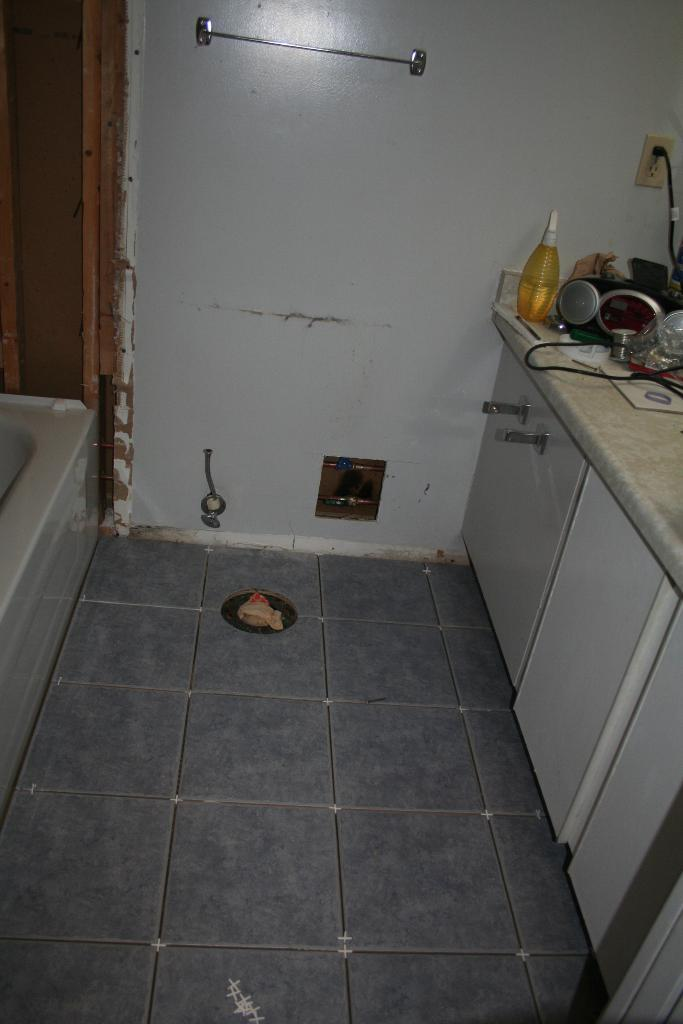What type of setting is shown in the image? The image depicts an inside view of a room. Can you describe any objects on the countertop in the room? There is a bottle on a countertop the countertop in the room, along with other unspecified items. What is the appearance of the metal rod on the wall in the background? The metal rod on the wall in the background is visible in the image. What type of club is the person holding in the image? There is no person or club present in the image; it shows an inside view of a room with a bottle on a countertop and a metal rod on the wall. 